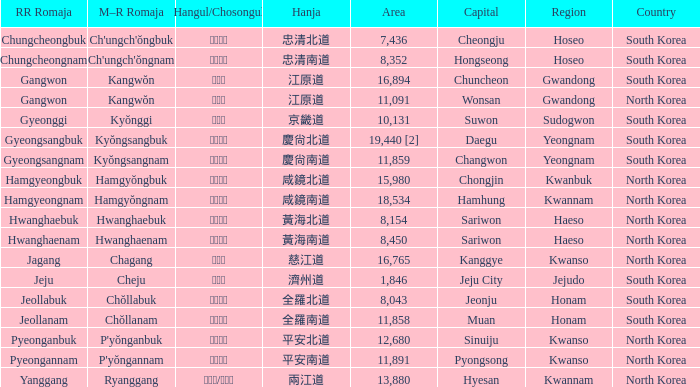What is the capital city with a hangul representation of 경상남도? Changwon. 